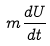<formula> <loc_0><loc_0><loc_500><loc_500>m \frac { d U } { d t }</formula> 